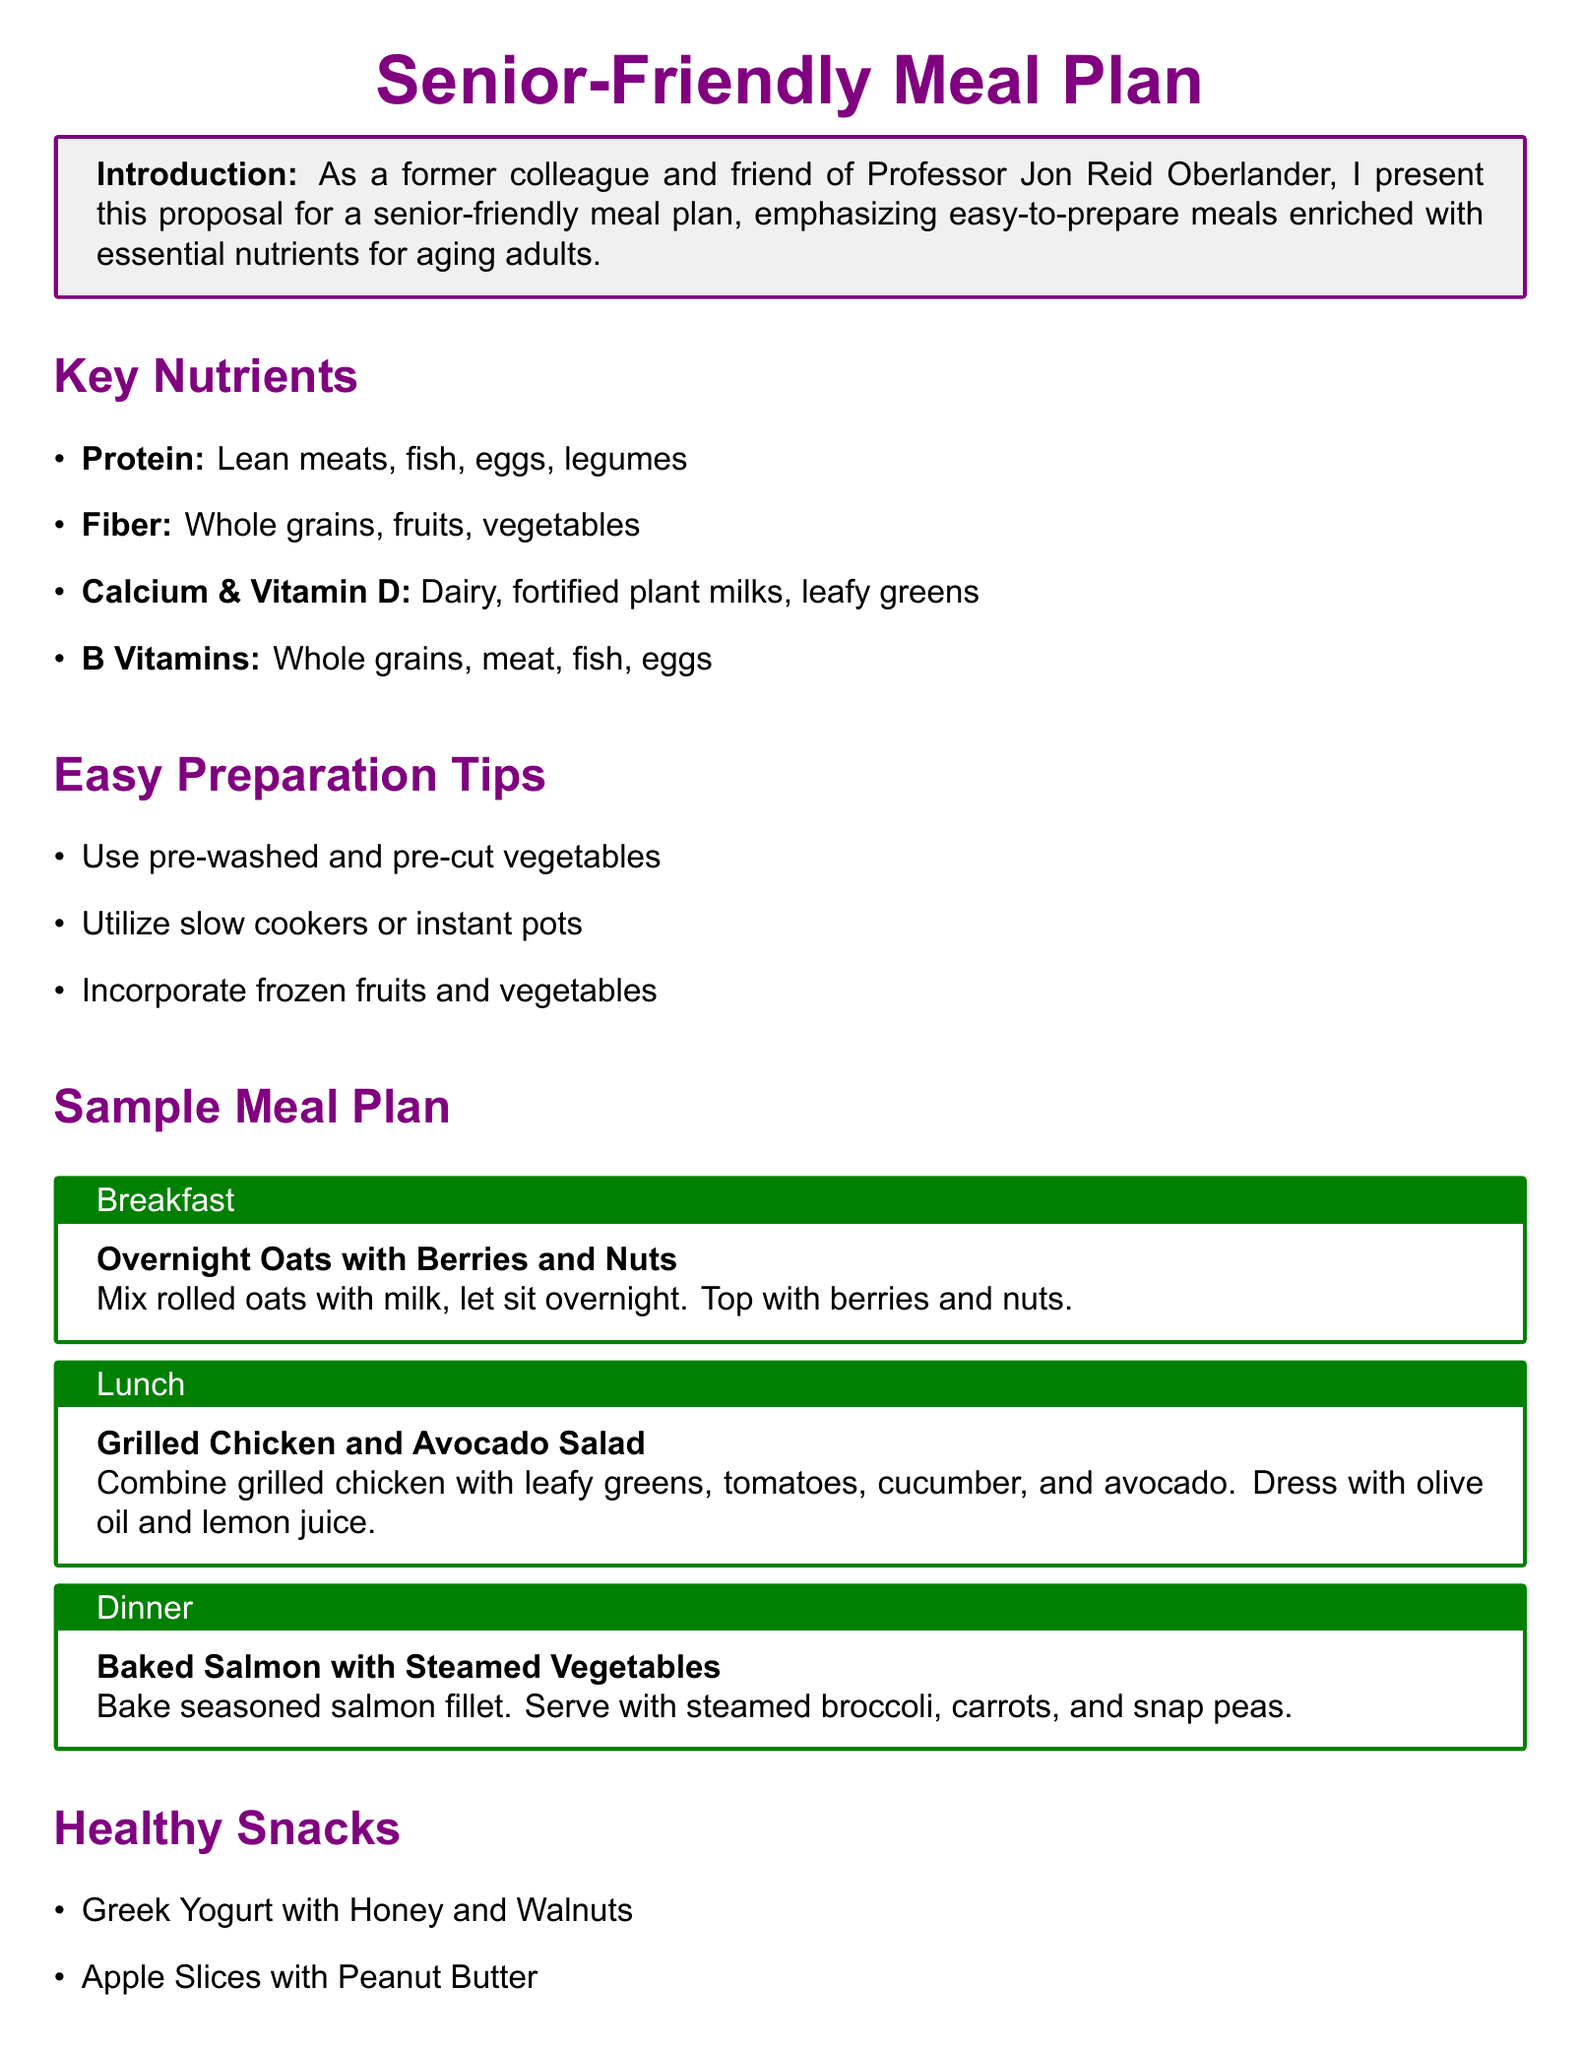What are the key nutrients emphasized in the meal plan? The key nutrients are listed in the section titled "Key Nutrients," detailing specific food sources for each nutrient.
Answer: Protein, Fiber, Calcium & Vitamin D, B Vitamins What type of meal is suggested for breakfast? The meal suggestion for breakfast can be found in the "Sample Meal Plan" section, specifically under the breakfast title.
Answer: Overnight Oats with Berries and Nuts What is one easy preparation tip mentioned in the document? An easy preparation tip can be found in the "Easy Preparation Tips" section, explaining ways to simplify cooking for seniors.
Answer: Use pre-washed and pre-cut vegetables Which food is mentioned as a healthy snack? The "Healthy Snacks" section lists various snack options available for seniors.
Answer: Greek Yogurt with Honey and Walnuts How many cups of water should seniors drink daily according to the hydration tips? The "Hydration Tips" section specifies the recommended daily water intake for seniors.
Answer: 8 cups What is the proposed dinner meal in the sample meal plan? The dinner meal is described in the "Sample Meal Plan" section under the dinner title.
Answer: Baked Salmon with Steamed Vegetables What is the color theme for the titles in this meal plan document? The color theme for titles can be interpreted from the use of color in the title formatting throughout the document.
Answer: Purple and Green What type of cuisine is indicated for lunch in the meal plan? The suggested lunch meal can be found under the "Sample Meal Plan" section, identifying the cuisine type used for that dish.
Answer: Salad 